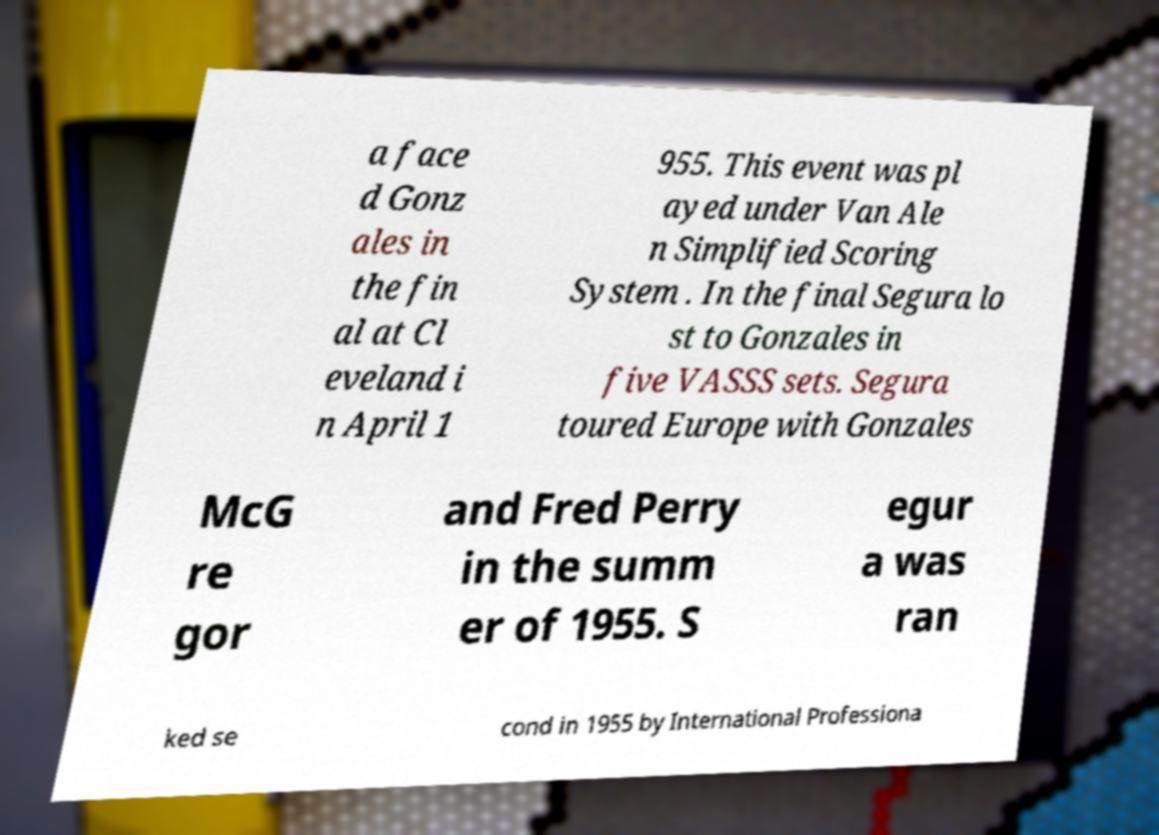I need the written content from this picture converted into text. Can you do that? a face d Gonz ales in the fin al at Cl eveland i n April 1 955. This event was pl ayed under Van Ale n Simplified Scoring System . In the final Segura lo st to Gonzales in five VASSS sets. Segura toured Europe with Gonzales McG re gor and Fred Perry in the summ er of 1955. S egur a was ran ked se cond in 1955 by International Professiona 